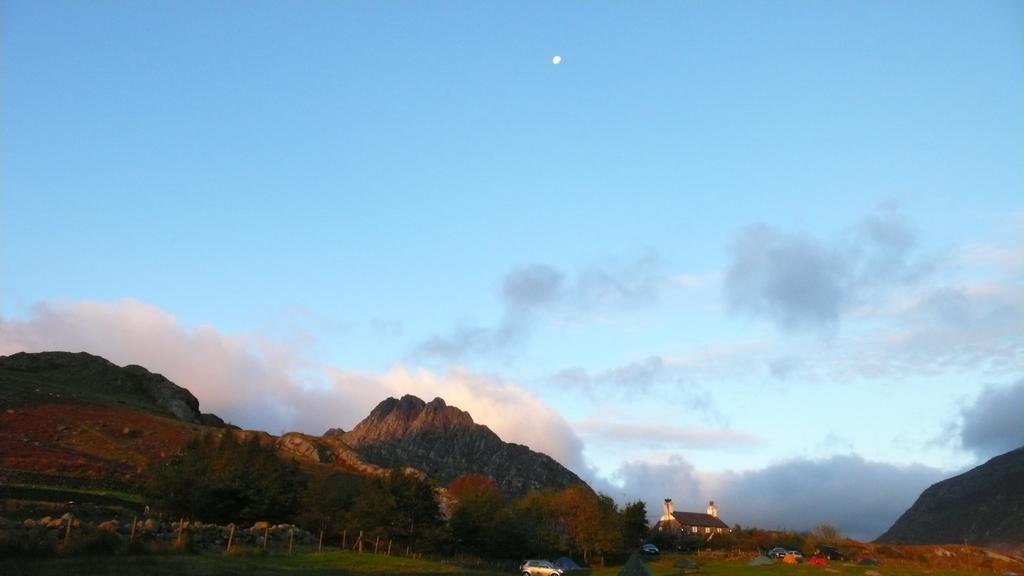How would you summarize this image in a sentence or two? In this image we can see a house with roof and windows. We can also see some vehicles on the ground, some poles, stones, the hills, the moon and the sky which looks cloudy. 